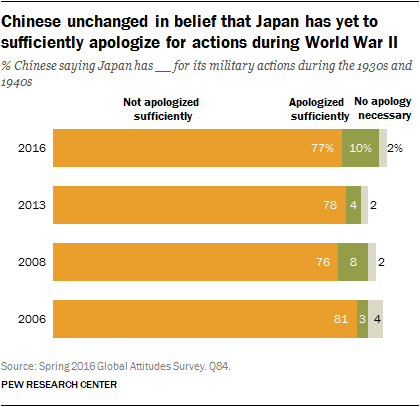How many colors are represented in the bar? There are four colors represented in the bar graph. Each color corresponds to a response category—orange for 'Not apologized sufficiently', light orange for 'Apologized sufficiently', green for 'No apology necessary', and gray for 'Don’t know/Refused to answer'. The bars illustrate the percentage of Chinese respondents to a survey about their views on Japan's apologies for its military actions during the 1930s and 1940s. 